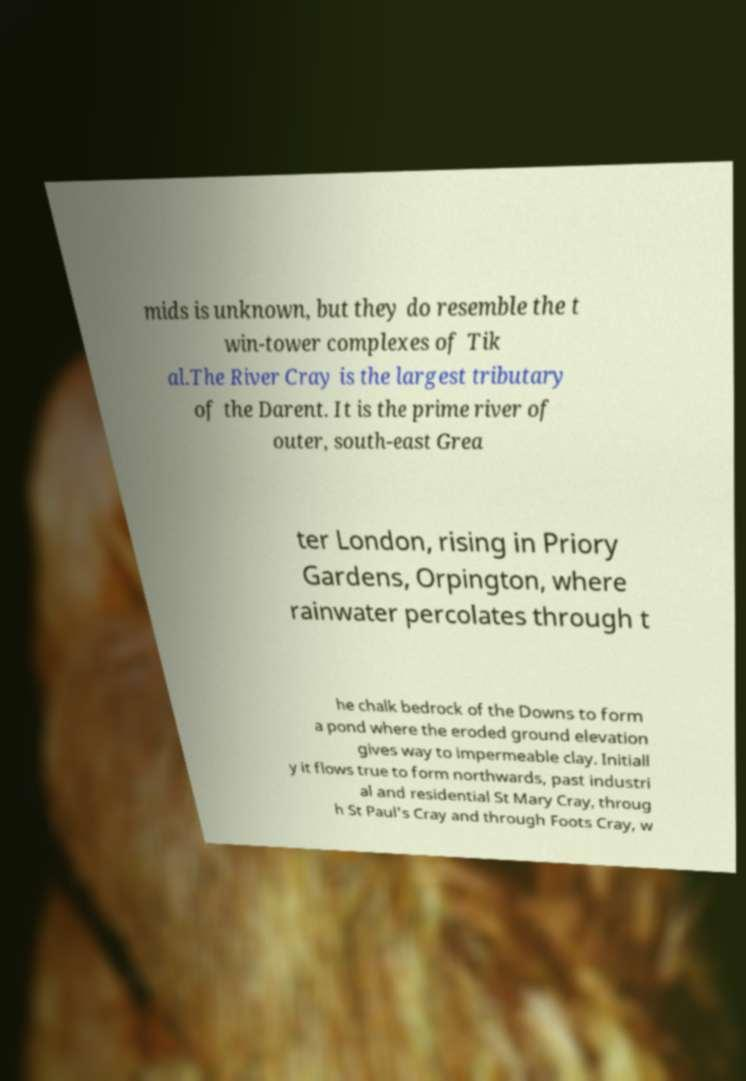What messages or text are displayed in this image? I need them in a readable, typed format. mids is unknown, but they do resemble the t win-tower complexes of Tik al.The River Cray is the largest tributary of the Darent. It is the prime river of outer, south-east Grea ter London, rising in Priory Gardens, Orpington, where rainwater percolates through t he chalk bedrock of the Downs to form a pond where the eroded ground elevation gives way to impermeable clay. Initiall y it flows true to form northwards, past industri al and residential St Mary Cray, throug h St Paul's Cray and through Foots Cray, w 